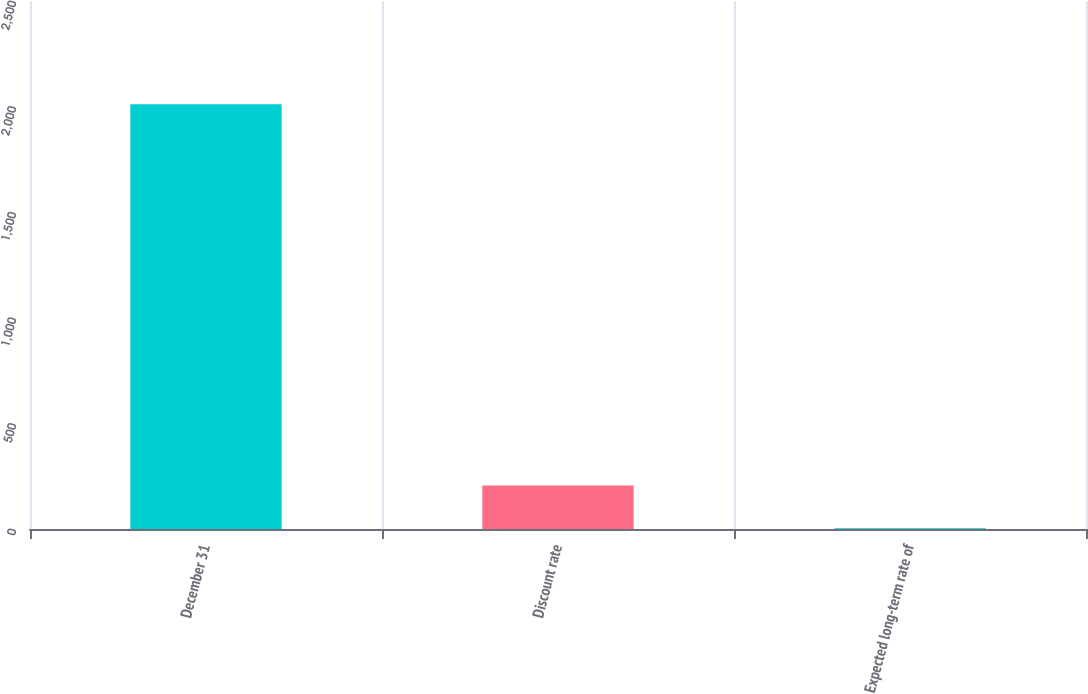Convert chart to OTSL. <chart><loc_0><loc_0><loc_500><loc_500><bar_chart><fcel>December 31<fcel>Discount rate<fcel>Expected long-term rate of<nl><fcel>2011<fcel>205.38<fcel>4.75<nl></chart> 